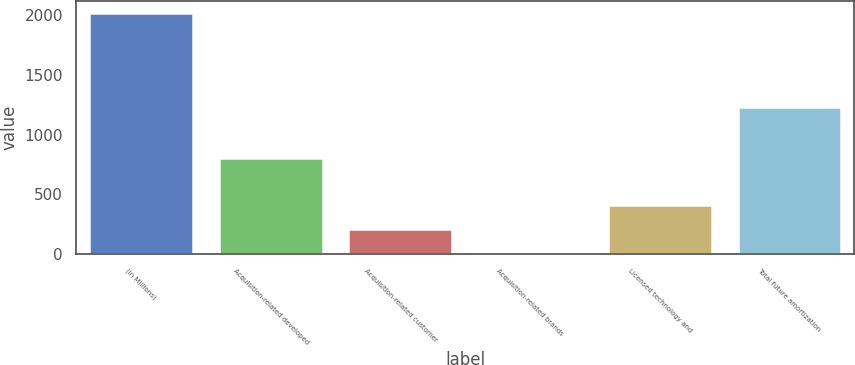Convert chart to OTSL. <chart><loc_0><loc_0><loc_500><loc_500><bar_chart><fcel>(In Millions)<fcel>Acquisition-related developed<fcel>Acquisition-related customer<fcel>Acquisition-related brands<fcel>Licensed technology and<fcel>Total future amortization<nl><fcel>2017<fcel>804<fcel>214.3<fcel>14<fcel>414.6<fcel>1234<nl></chart> 